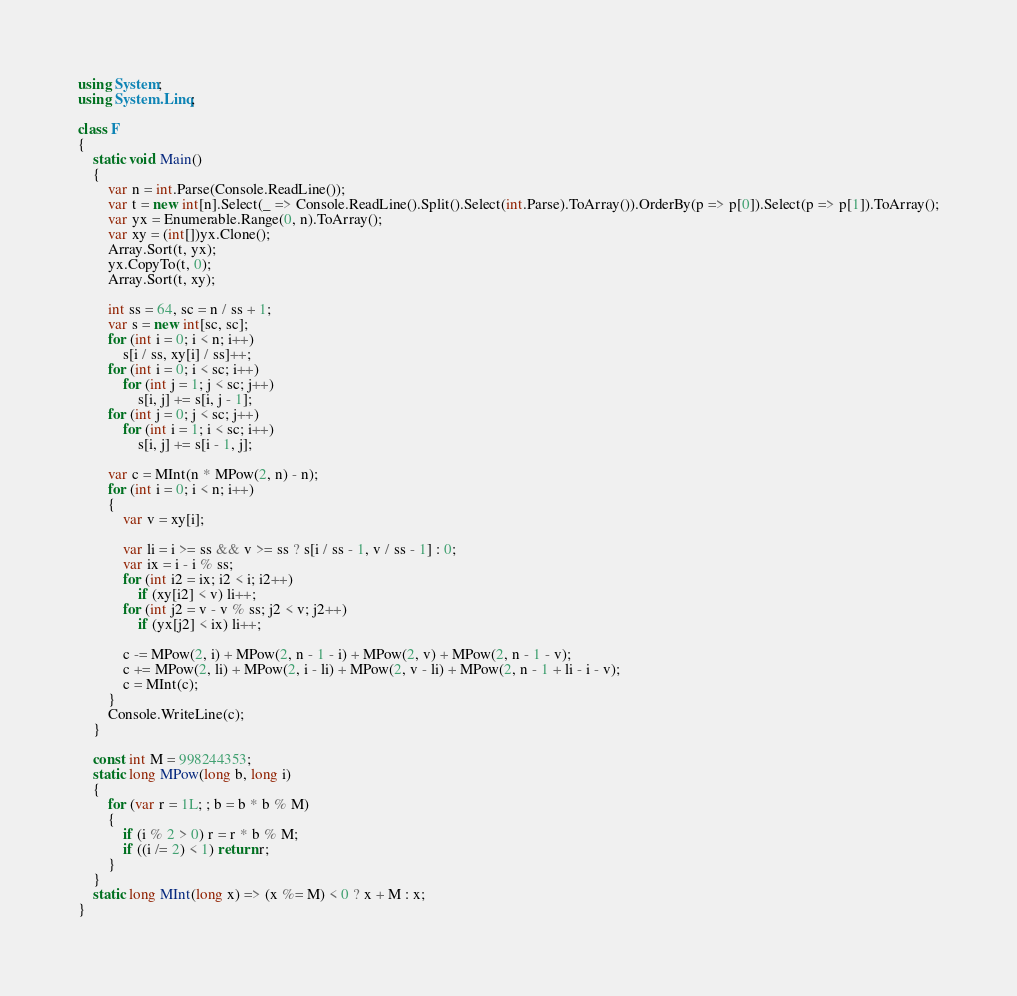<code> <loc_0><loc_0><loc_500><loc_500><_C#_>using System;
using System.Linq;

class F
{
	static void Main()
	{
		var n = int.Parse(Console.ReadLine());
		var t = new int[n].Select(_ => Console.ReadLine().Split().Select(int.Parse).ToArray()).OrderBy(p => p[0]).Select(p => p[1]).ToArray();
		var yx = Enumerable.Range(0, n).ToArray();
		var xy = (int[])yx.Clone();
		Array.Sort(t, yx);
		yx.CopyTo(t, 0);
		Array.Sort(t, xy);

		int ss = 64, sc = n / ss + 1;
		var s = new int[sc, sc];
		for (int i = 0; i < n; i++)
			s[i / ss, xy[i] / ss]++;
		for (int i = 0; i < sc; i++)
			for (int j = 1; j < sc; j++)
				s[i, j] += s[i, j - 1];
		for (int j = 0; j < sc; j++)
			for (int i = 1; i < sc; i++)
				s[i, j] += s[i - 1, j];

		var c = MInt(n * MPow(2, n) - n);
		for (int i = 0; i < n; i++)
		{
			var v = xy[i];

			var li = i >= ss && v >= ss ? s[i / ss - 1, v / ss - 1] : 0;
			var ix = i - i % ss;
			for (int i2 = ix; i2 < i; i2++)
				if (xy[i2] < v) li++;
			for (int j2 = v - v % ss; j2 < v; j2++)
				if (yx[j2] < ix) li++;

			c -= MPow(2, i) + MPow(2, n - 1 - i) + MPow(2, v) + MPow(2, n - 1 - v);
			c += MPow(2, li) + MPow(2, i - li) + MPow(2, v - li) + MPow(2, n - 1 + li - i - v);
			c = MInt(c);
		}
		Console.WriteLine(c);
	}

	const int M = 998244353;
	static long MPow(long b, long i)
	{
		for (var r = 1L; ; b = b * b % M)
		{
			if (i % 2 > 0) r = r * b % M;
			if ((i /= 2) < 1) return r;
		}
	}
	static long MInt(long x) => (x %= M) < 0 ? x + M : x;
}
</code> 